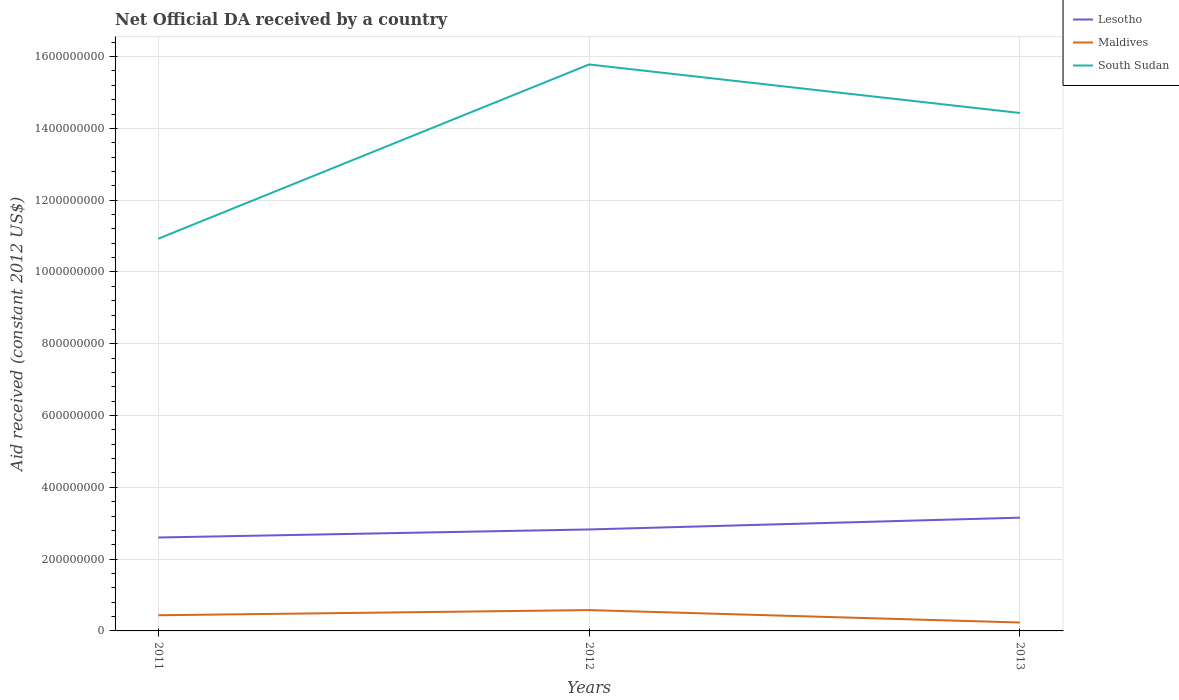How many different coloured lines are there?
Your answer should be compact. 3. Does the line corresponding to Lesotho intersect with the line corresponding to South Sudan?
Your response must be concise. No. Is the number of lines equal to the number of legend labels?
Provide a short and direct response. Yes. Across all years, what is the maximum net official development assistance aid received in Maldives?
Your answer should be compact. 2.34e+07. In which year was the net official development assistance aid received in Lesotho maximum?
Offer a terse response. 2011. What is the total net official development assistance aid received in Lesotho in the graph?
Provide a short and direct response. -2.24e+07. What is the difference between the highest and the second highest net official development assistance aid received in Lesotho?
Your answer should be very brief. 5.52e+07. How many lines are there?
Your answer should be compact. 3. What is the difference between two consecutive major ticks on the Y-axis?
Provide a short and direct response. 2.00e+08. Does the graph contain any zero values?
Make the answer very short. No. Does the graph contain grids?
Give a very brief answer. Yes. What is the title of the graph?
Provide a succinct answer. Net Official DA received by a country. What is the label or title of the X-axis?
Offer a very short reply. Years. What is the label or title of the Y-axis?
Your answer should be very brief. Aid received (constant 2012 US$). What is the Aid received (constant 2012 US$) in Lesotho in 2011?
Offer a terse response. 2.60e+08. What is the Aid received (constant 2012 US$) in Maldives in 2011?
Keep it short and to the point. 4.36e+07. What is the Aid received (constant 2012 US$) of South Sudan in 2011?
Offer a terse response. 1.09e+09. What is the Aid received (constant 2012 US$) of Lesotho in 2012?
Provide a succinct answer. 2.83e+08. What is the Aid received (constant 2012 US$) of Maldives in 2012?
Offer a very short reply. 5.80e+07. What is the Aid received (constant 2012 US$) of South Sudan in 2012?
Provide a succinct answer. 1.58e+09. What is the Aid received (constant 2012 US$) of Lesotho in 2013?
Make the answer very short. 3.15e+08. What is the Aid received (constant 2012 US$) in Maldives in 2013?
Offer a terse response. 2.34e+07. What is the Aid received (constant 2012 US$) of South Sudan in 2013?
Provide a succinct answer. 1.44e+09. Across all years, what is the maximum Aid received (constant 2012 US$) in Lesotho?
Make the answer very short. 3.15e+08. Across all years, what is the maximum Aid received (constant 2012 US$) of Maldives?
Offer a terse response. 5.80e+07. Across all years, what is the maximum Aid received (constant 2012 US$) in South Sudan?
Give a very brief answer. 1.58e+09. Across all years, what is the minimum Aid received (constant 2012 US$) of Lesotho?
Your answer should be compact. 2.60e+08. Across all years, what is the minimum Aid received (constant 2012 US$) of Maldives?
Keep it short and to the point. 2.34e+07. Across all years, what is the minimum Aid received (constant 2012 US$) in South Sudan?
Your answer should be compact. 1.09e+09. What is the total Aid received (constant 2012 US$) in Lesotho in the graph?
Provide a succinct answer. 8.58e+08. What is the total Aid received (constant 2012 US$) in Maldives in the graph?
Make the answer very short. 1.25e+08. What is the total Aid received (constant 2012 US$) in South Sudan in the graph?
Offer a terse response. 4.11e+09. What is the difference between the Aid received (constant 2012 US$) in Lesotho in 2011 and that in 2012?
Your answer should be very brief. -2.24e+07. What is the difference between the Aid received (constant 2012 US$) of Maldives in 2011 and that in 2012?
Provide a succinct answer. -1.44e+07. What is the difference between the Aid received (constant 2012 US$) of South Sudan in 2011 and that in 2012?
Offer a terse response. -4.85e+08. What is the difference between the Aid received (constant 2012 US$) of Lesotho in 2011 and that in 2013?
Make the answer very short. -5.52e+07. What is the difference between the Aid received (constant 2012 US$) in Maldives in 2011 and that in 2013?
Offer a terse response. 2.02e+07. What is the difference between the Aid received (constant 2012 US$) in South Sudan in 2011 and that in 2013?
Offer a very short reply. -3.50e+08. What is the difference between the Aid received (constant 2012 US$) of Lesotho in 2012 and that in 2013?
Offer a terse response. -3.28e+07. What is the difference between the Aid received (constant 2012 US$) of Maldives in 2012 and that in 2013?
Provide a short and direct response. 3.46e+07. What is the difference between the Aid received (constant 2012 US$) in South Sudan in 2012 and that in 2013?
Provide a succinct answer. 1.35e+08. What is the difference between the Aid received (constant 2012 US$) of Lesotho in 2011 and the Aid received (constant 2012 US$) of Maldives in 2012?
Your answer should be compact. 2.02e+08. What is the difference between the Aid received (constant 2012 US$) in Lesotho in 2011 and the Aid received (constant 2012 US$) in South Sudan in 2012?
Give a very brief answer. -1.32e+09. What is the difference between the Aid received (constant 2012 US$) in Maldives in 2011 and the Aid received (constant 2012 US$) in South Sudan in 2012?
Provide a succinct answer. -1.53e+09. What is the difference between the Aid received (constant 2012 US$) of Lesotho in 2011 and the Aid received (constant 2012 US$) of Maldives in 2013?
Ensure brevity in your answer.  2.37e+08. What is the difference between the Aid received (constant 2012 US$) of Lesotho in 2011 and the Aid received (constant 2012 US$) of South Sudan in 2013?
Your answer should be compact. -1.18e+09. What is the difference between the Aid received (constant 2012 US$) of Maldives in 2011 and the Aid received (constant 2012 US$) of South Sudan in 2013?
Your answer should be compact. -1.40e+09. What is the difference between the Aid received (constant 2012 US$) in Lesotho in 2012 and the Aid received (constant 2012 US$) in Maldives in 2013?
Your answer should be very brief. 2.59e+08. What is the difference between the Aid received (constant 2012 US$) of Lesotho in 2012 and the Aid received (constant 2012 US$) of South Sudan in 2013?
Keep it short and to the point. -1.16e+09. What is the difference between the Aid received (constant 2012 US$) of Maldives in 2012 and the Aid received (constant 2012 US$) of South Sudan in 2013?
Provide a succinct answer. -1.38e+09. What is the average Aid received (constant 2012 US$) in Lesotho per year?
Provide a succinct answer. 2.86e+08. What is the average Aid received (constant 2012 US$) in Maldives per year?
Provide a succinct answer. 4.17e+07. What is the average Aid received (constant 2012 US$) of South Sudan per year?
Ensure brevity in your answer.  1.37e+09. In the year 2011, what is the difference between the Aid received (constant 2012 US$) in Lesotho and Aid received (constant 2012 US$) in Maldives?
Offer a terse response. 2.17e+08. In the year 2011, what is the difference between the Aid received (constant 2012 US$) of Lesotho and Aid received (constant 2012 US$) of South Sudan?
Your answer should be compact. -8.32e+08. In the year 2011, what is the difference between the Aid received (constant 2012 US$) of Maldives and Aid received (constant 2012 US$) of South Sudan?
Offer a very short reply. -1.05e+09. In the year 2012, what is the difference between the Aid received (constant 2012 US$) of Lesotho and Aid received (constant 2012 US$) of Maldives?
Make the answer very short. 2.25e+08. In the year 2012, what is the difference between the Aid received (constant 2012 US$) in Lesotho and Aid received (constant 2012 US$) in South Sudan?
Make the answer very short. -1.30e+09. In the year 2012, what is the difference between the Aid received (constant 2012 US$) in Maldives and Aid received (constant 2012 US$) in South Sudan?
Ensure brevity in your answer.  -1.52e+09. In the year 2013, what is the difference between the Aid received (constant 2012 US$) in Lesotho and Aid received (constant 2012 US$) in Maldives?
Ensure brevity in your answer.  2.92e+08. In the year 2013, what is the difference between the Aid received (constant 2012 US$) of Lesotho and Aid received (constant 2012 US$) of South Sudan?
Ensure brevity in your answer.  -1.13e+09. In the year 2013, what is the difference between the Aid received (constant 2012 US$) in Maldives and Aid received (constant 2012 US$) in South Sudan?
Keep it short and to the point. -1.42e+09. What is the ratio of the Aid received (constant 2012 US$) of Lesotho in 2011 to that in 2012?
Give a very brief answer. 0.92. What is the ratio of the Aid received (constant 2012 US$) of Maldives in 2011 to that in 2012?
Make the answer very short. 0.75. What is the ratio of the Aid received (constant 2012 US$) in South Sudan in 2011 to that in 2012?
Ensure brevity in your answer.  0.69. What is the ratio of the Aid received (constant 2012 US$) of Lesotho in 2011 to that in 2013?
Ensure brevity in your answer.  0.82. What is the ratio of the Aid received (constant 2012 US$) in Maldives in 2011 to that in 2013?
Ensure brevity in your answer.  1.86. What is the ratio of the Aid received (constant 2012 US$) of South Sudan in 2011 to that in 2013?
Offer a very short reply. 0.76. What is the ratio of the Aid received (constant 2012 US$) in Lesotho in 2012 to that in 2013?
Keep it short and to the point. 0.9. What is the ratio of the Aid received (constant 2012 US$) of Maldives in 2012 to that in 2013?
Offer a very short reply. 2.48. What is the ratio of the Aid received (constant 2012 US$) of South Sudan in 2012 to that in 2013?
Your response must be concise. 1.09. What is the difference between the highest and the second highest Aid received (constant 2012 US$) of Lesotho?
Provide a short and direct response. 3.28e+07. What is the difference between the highest and the second highest Aid received (constant 2012 US$) of Maldives?
Your answer should be compact. 1.44e+07. What is the difference between the highest and the second highest Aid received (constant 2012 US$) of South Sudan?
Make the answer very short. 1.35e+08. What is the difference between the highest and the lowest Aid received (constant 2012 US$) of Lesotho?
Ensure brevity in your answer.  5.52e+07. What is the difference between the highest and the lowest Aid received (constant 2012 US$) of Maldives?
Provide a short and direct response. 3.46e+07. What is the difference between the highest and the lowest Aid received (constant 2012 US$) in South Sudan?
Give a very brief answer. 4.85e+08. 